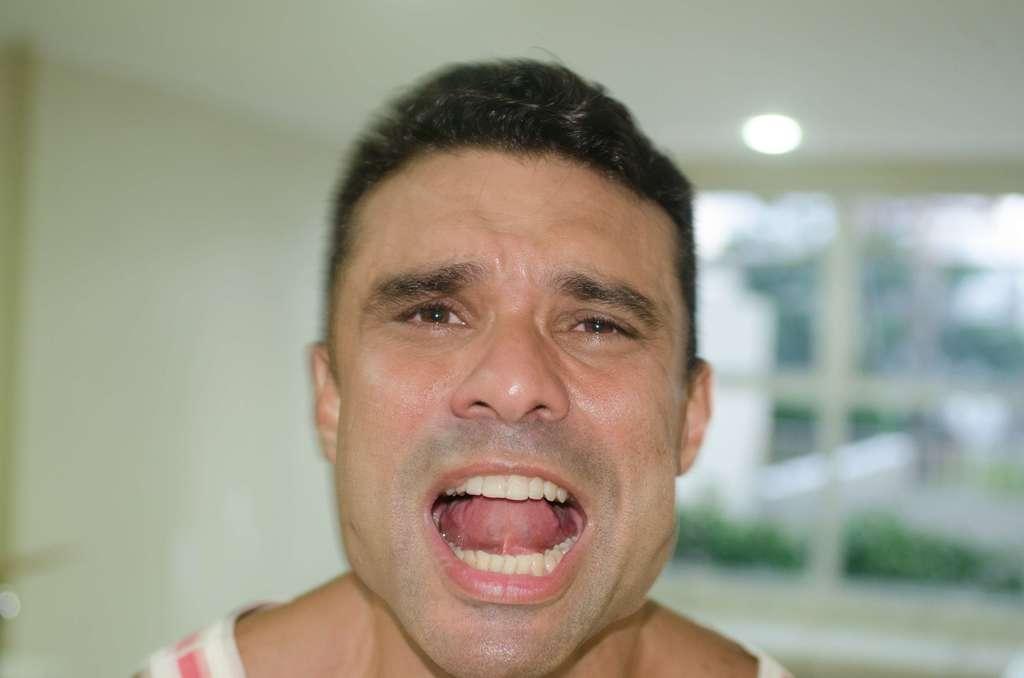Please provide a concise description of this image. In this picture we can see a man, in the background we can see a light. 